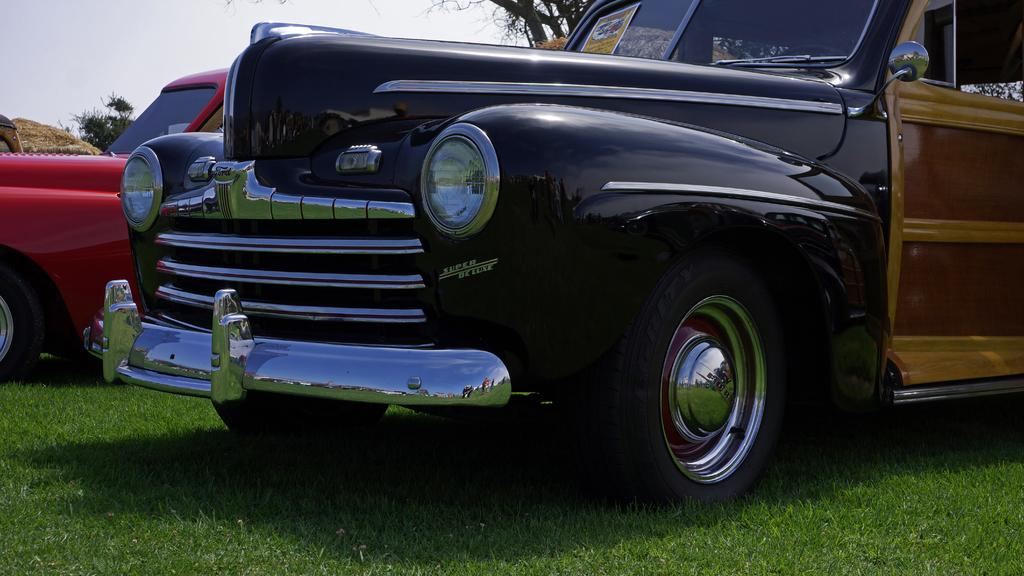What type of vehicles can be seen in the image? There are cars in the image. What is the ground surface like in the image? There is grass on the ground in the image. What can be seen in the background of the image? There is sky and trees visible in the background of the image. What type of linen is being used to cover the cars in the image? There is no linen present in the image, and the cars are not covered. 